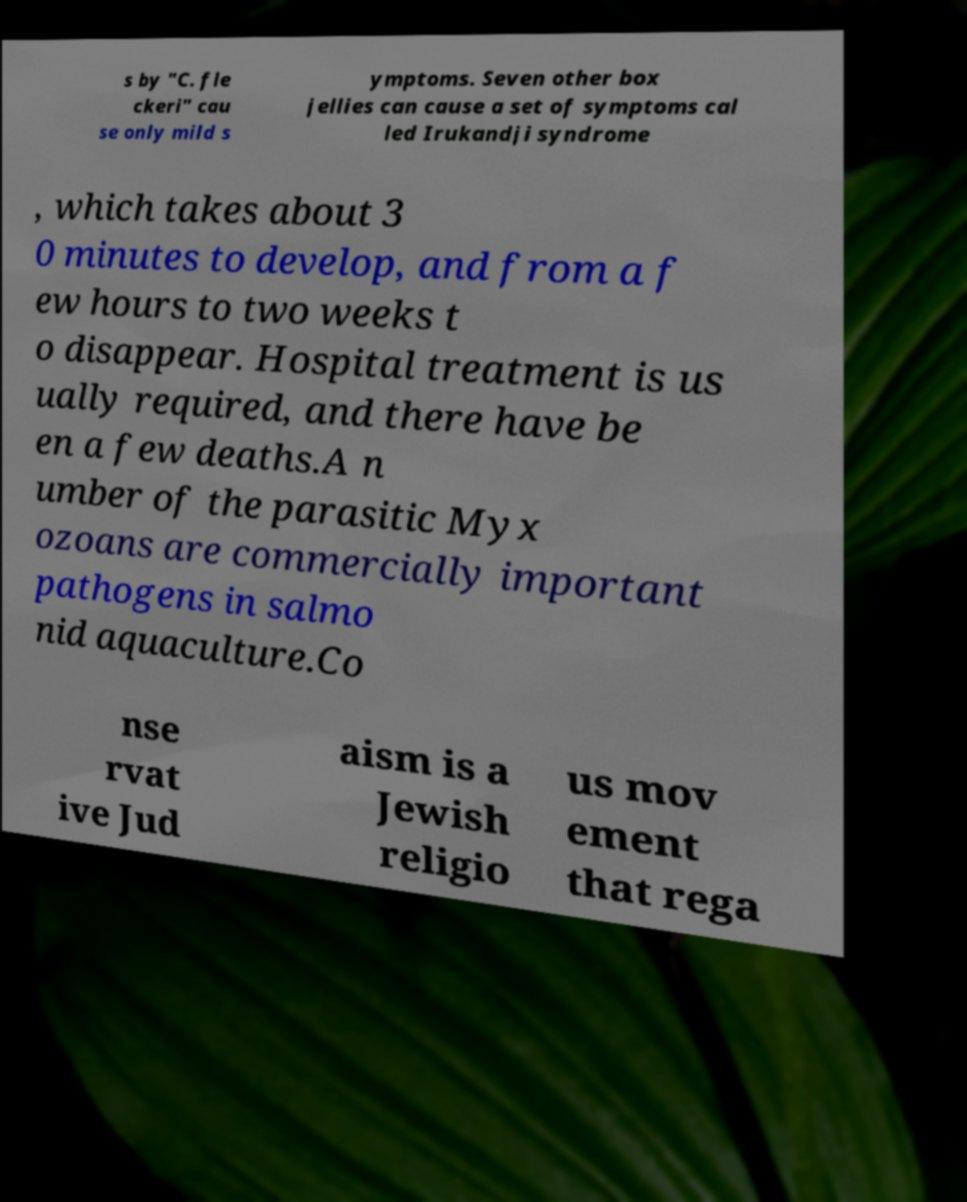Could you assist in decoding the text presented in this image and type it out clearly? s by "C. fle ckeri" cau se only mild s ymptoms. Seven other box jellies can cause a set of symptoms cal led Irukandji syndrome , which takes about 3 0 minutes to develop, and from a f ew hours to two weeks t o disappear. Hospital treatment is us ually required, and there have be en a few deaths.A n umber of the parasitic Myx ozoans are commercially important pathogens in salmo nid aquaculture.Co nse rvat ive Jud aism is a Jewish religio us mov ement that rega 